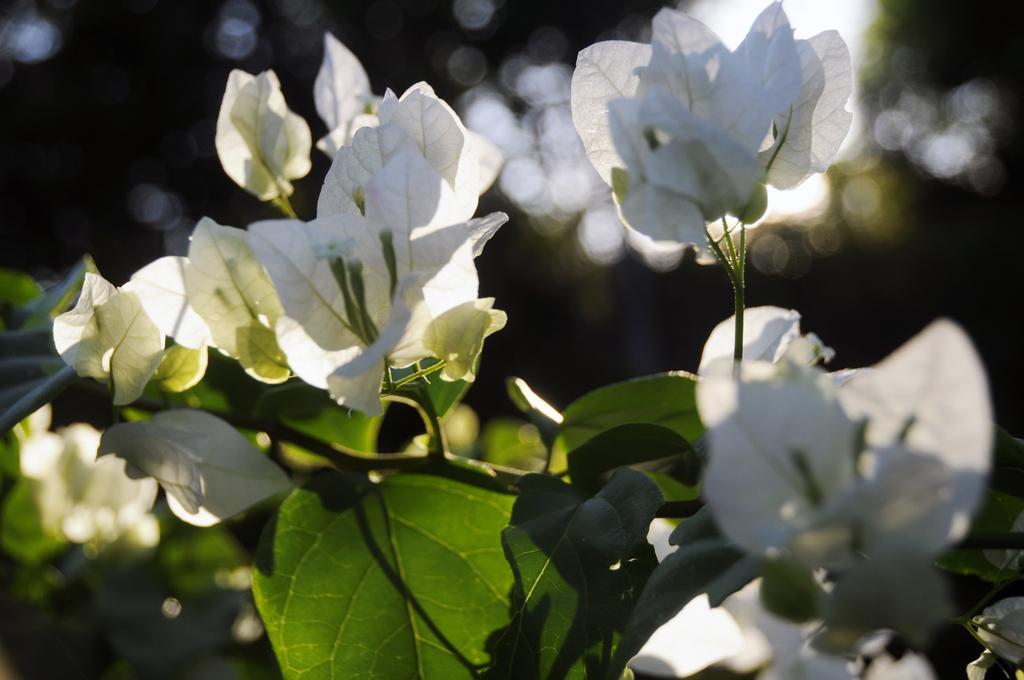In one or two sentences, can you explain what this image depicts? In the image there is a tree with white and green leaves. 